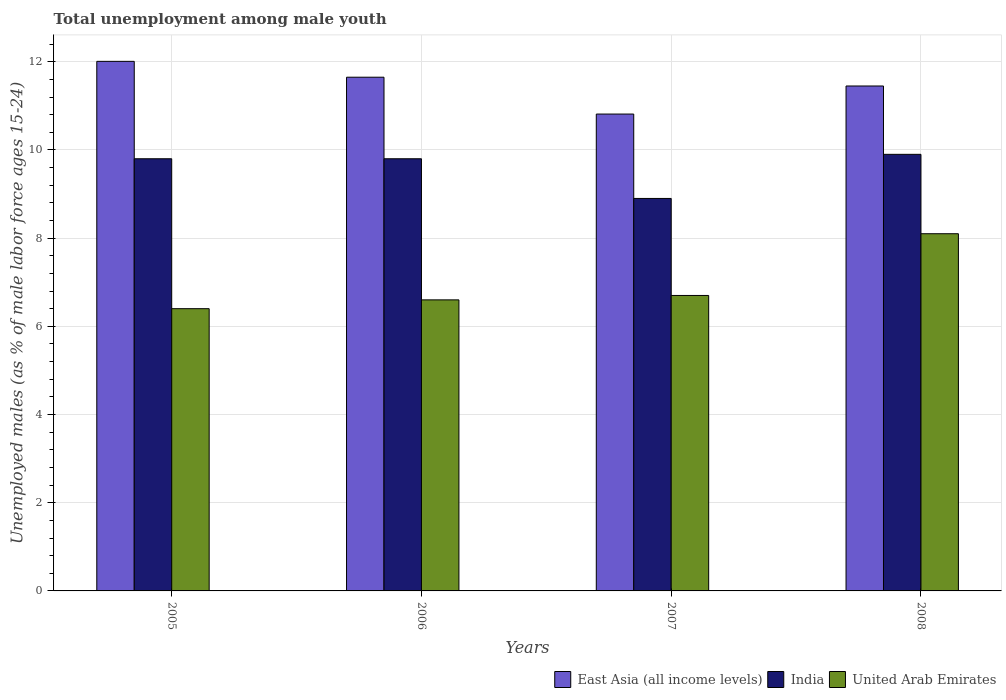How many groups of bars are there?
Ensure brevity in your answer.  4. Are the number of bars per tick equal to the number of legend labels?
Offer a very short reply. Yes. How many bars are there on the 3rd tick from the left?
Keep it short and to the point. 3. What is the percentage of unemployed males in in India in 2008?
Offer a terse response. 9.9. Across all years, what is the maximum percentage of unemployed males in in East Asia (all income levels)?
Make the answer very short. 12.01. Across all years, what is the minimum percentage of unemployed males in in East Asia (all income levels)?
Your response must be concise. 10.81. In which year was the percentage of unemployed males in in United Arab Emirates maximum?
Give a very brief answer. 2008. In which year was the percentage of unemployed males in in India minimum?
Your answer should be compact. 2007. What is the total percentage of unemployed males in in United Arab Emirates in the graph?
Make the answer very short. 27.8. What is the difference between the percentage of unemployed males in in United Arab Emirates in 2005 and that in 2008?
Your answer should be compact. -1.7. What is the difference between the percentage of unemployed males in in India in 2007 and the percentage of unemployed males in in East Asia (all income levels) in 2005?
Give a very brief answer. -3.11. What is the average percentage of unemployed males in in United Arab Emirates per year?
Provide a succinct answer. 6.95. In the year 2008, what is the difference between the percentage of unemployed males in in United Arab Emirates and percentage of unemployed males in in India?
Offer a terse response. -1.8. In how many years, is the percentage of unemployed males in in United Arab Emirates greater than 6.4 %?
Ensure brevity in your answer.  4. What is the ratio of the percentage of unemployed males in in East Asia (all income levels) in 2006 to that in 2007?
Keep it short and to the point. 1.08. Is the difference between the percentage of unemployed males in in United Arab Emirates in 2007 and 2008 greater than the difference between the percentage of unemployed males in in India in 2007 and 2008?
Offer a terse response. No. What is the difference between the highest and the second highest percentage of unemployed males in in United Arab Emirates?
Your answer should be very brief. 1.4. What is the difference between the highest and the lowest percentage of unemployed males in in East Asia (all income levels)?
Provide a succinct answer. 1.2. In how many years, is the percentage of unemployed males in in United Arab Emirates greater than the average percentage of unemployed males in in United Arab Emirates taken over all years?
Provide a succinct answer. 1. Is the sum of the percentage of unemployed males in in East Asia (all income levels) in 2006 and 2007 greater than the maximum percentage of unemployed males in in United Arab Emirates across all years?
Offer a very short reply. Yes. What does the 1st bar from the left in 2005 represents?
Provide a short and direct response. East Asia (all income levels). What does the 3rd bar from the right in 2006 represents?
Keep it short and to the point. East Asia (all income levels). Is it the case that in every year, the sum of the percentage of unemployed males in in East Asia (all income levels) and percentage of unemployed males in in India is greater than the percentage of unemployed males in in United Arab Emirates?
Make the answer very short. Yes. How many bars are there?
Your response must be concise. 12. What is the difference between two consecutive major ticks on the Y-axis?
Offer a terse response. 2. Are the values on the major ticks of Y-axis written in scientific E-notation?
Your answer should be compact. No. Does the graph contain any zero values?
Ensure brevity in your answer.  No. Does the graph contain grids?
Give a very brief answer. Yes. How are the legend labels stacked?
Your response must be concise. Horizontal. What is the title of the graph?
Keep it short and to the point. Total unemployment among male youth. What is the label or title of the Y-axis?
Make the answer very short. Unemployed males (as % of male labor force ages 15-24). What is the Unemployed males (as % of male labor force ages 15-24) in East Asia (all income levels) in 2005?
Offer a very short reply. 12.01. What is the Unemployed males (as % of male labor force ages 15-24) of India in 2005?
Offer a very short reply. 9.8. What is the Unemployed males (as % of male labor force ages 15-24) of United Arab Emirates in 2005?
Keep it short and to the point. 6.4. What is the Unemployed males (as % of male labor force ages 15-24) in East Asia (all income levels) in 2006?
Offer a terse response. 11.65. What is the Unemployed males (as % of male labor force ages 15-24) in India in 2006?
Your answer should be very brief. 9.8. What is the Unemployed males (as % of male labor force ages 15-24) of United Arab Emirates in 2006?
Provide a short and direct response. 6.6. What is the Unemployed males (as % of male labor force ages 15-24) in East Asia (all income levels) in 2007?
Provide a succinct answer. 10.81. What is the Unemployed males (as % of male labor force ages 15-24) of India in 2007?
Offer a terse response. 8.9. What is the Unemployed males (as % of male labor force ages 15-24) in United Arab Emirates in 2007?
Ensure brevity in your answer.  6.7. What is the Unemployed males (as % of male labor force ages 15-24) in East Asia (all income levels) in 2008?
Provide a succinct answer. 11.45. What is the Unemployed males (as % of male labor force ages 15-24) in India in 2008?
Offer a terse response. 9.9. What is the Unemployed males (as % of male labor force ages 15-24) in United Arab Emirates in 2008?
Your answer should be compact. 8.1. Across all years, what is the maximum Unemployed males (as % of male labor force ages 15-24) in East Asia (all income levels)?
Provide a short and direct response. 12.01. Across all years, what is the maximum Unemployed males (as % of male labor force ages 15-24) in India?
Offer a terse response. 9.9. Across all years, what is the maximum Unemployed males (as % of male labor force ages 15-24) in United Arab Emirates?
Provide a succinct answer. 8.1. Across all years, what is the minimum Unemployed males (as % of male labor force ages 15-24) of East Asia (all income levels)?
Provide a succinct answer. 10.81. Across all years, what is the minimum Unemployed males (as % of male labor force ages 15-24) in India?
Your response must be concise. 8.9. Across all years, what is the minimum Unemployed males (as % of male labor force ages 15-24) in United Arab Emirates?
Make the answer very short. 6.4. What is the total Unemployed males (as % of male labor force ages 15-24) in East Asia (all income levels) in the graph?
Provide a short and direct response. 45.92. What is the total Unemployed males (as % of male labor force ages 15-24) in India in the graph?
Keep it short and to the point. 38.4. What is the total Unemployed males (as % of male labor force ages 15-24) of United Arab Emirates in the graph?
Offer a terse response. 27.8. What is the difference between the Unemployed males (as % of male labor force ages 15-24) in East Asia (all income levels) in 2005 and that in 2006?
Ensure brevity in your answer.  0.36. What is the difference between the Unemployed males (as % of male labor force ages 15-24) in East Asia (all income levels) in 2005 and that in 2007?
Give a very brief answer. 1.2. What is the difference between the Unemployed males (as % of male labor force ages 15-24) in India in 2005 and that in 2007?
Offer a very short reply. 0.9. What is the difference between the Unemployed males (as % of male labor force ages 15-24) of East Asia (all income levels) in 2005 and that in 2008?
Offer a very short reply. 0.56. What is the difference between the Unemployed males (as % of male labor force ages 15-24) of India in 2005 and that in 2008?
Offer a terse response. -0.1. What is the difference between the Unemployed males (as % of male labor force ages 15-24) in East Asia (all income levels) in 2006 and that in 2007?
Your response must be concise. 0.84. What is the difference between the Unemployed males (as % of male labor force ages 15-24) of India in 2006 and that in 2007?
Your answer should be very brief. 0.9. What is the difference between the Unemployed males (as % of male labor force ages 15-24) in East Asia (all income levels) in 2006 and that in 2008?
Provide a short and direct response. 0.2. What is the difference between the Unemployed males (as % of male labor force ages 15-24) in United Arab Emirates in 2006 and that in 2008?
Offer a terse response. -1.5. What is the difference between the Unemployed males (as % of male labor force ages 15-24) in East Asia (all income levels) in 2007 and that in 2008?
Your response must be concise. -0.64. What is the difference between the Unemployed males (as % of male labor force ages 15-24) of India in 2007 and that in 2008?
Keep it short and to the point. -1. What is the difference between the Unemployed males (as % of male labor force ages 15-24) of East Asia (all income levels) in 2005 and the Unemployed males (as % of male labor force ages 15-24) of India in 2006?
Offer a terse response. 2.21. What is the difference between the Unemployed males (as % of male labor force ages 15-24) in East Asia (all income levels) in 2005 and the Unemployed males (as % of male labor force ages 15-24) in United Arab Emirates in 2006?
Offer a very short reply. 5.41. What is the difference between the Unemployed males (as % of male labor force ages 15-24) of East Asia (all income levels) in 2005 and the Unemployed males (as % of male labor force ages 15-24) of India in 2007?
Your answer should be very brief. 3.11. What is the difference between the Unemployed males (as % of male labor force ages 15-24) in East Asia (all income levels) in 2005 and the Unemployed males (as % of male labor force ages 15-24) in United Arab Emirates in 2007?
Provide a short and direct response. 5.31. What is the difference between the Unemployed males (as % of male labor force ages 15-24) in East Asia (all income levels) in 2005 and the Unemployed males (as % of male labor force ages 15-24) in India in 2008?
Make the answer very short. 2.11. What is the difference between the Unemployed males (as % of male labor force ages 15-24) of East Asia (all income levels) in 2005 and the Unemployed males (as % of male labor force ages 15-24) of United Arab Emirates in 2008?
Give a very brief answer. 3.91. What is the difference between the Unemployed males (as % of male labor force ages 15-24) in India in 2005 and the Unemployed males (as % of male labor force ages 15-24) in United Arab Emirates in 2008?
Keep it short and to the point. 1.7. What is the difference between the Unemployed males (as % of male labor force ages 15-24) of East Asia (all income levels) in 2006 and the Unemployed males (as % of male labor force ages 15-24) of India in 2007?
Offer a terse response. 2.75. What is the difference between the Unemployed males (as % of male labor force ages 15-24) of East Asia (all income levels) in 2006 and the Unemployed males (as % of male labor force ages 15-24) of United Arab Emirates in 2007?
Your answer should be compact. 4.95. What is the difference between the Unemployed males (as % of male labor force ages 15-24) of India in 2006 and the Unemployed males (as % of male labor force ages 15-24) of United Arab Emirates in 2007?
Provide a short and direct response. 3.1. What is the difference between the Unemployed males (as % of male labor force ages 15-24) of East Asia (all income levels) in 2006 and the Unemployed males (as % of male labor force ages 15-24) of India in 2008?
Make the answer very short. 1.75. What is the difference between the Unemployed males (as % of male labor force ages 15-24) in East Asia (all income levels) in 2006 and the Unemployed males (as % of male labor force ages 15-24) in United Arab Emirates in 2008?
Offer a terse response. 3.55. What is the difference between the Unemployed males (as % of male labor force ages 15-24) of India in 2006 and the Unemployed males (as % of male labor force ages 15-24) of United Arab Emirates in 2008?
Your response must be concise. 1.7. What is the difference between the Unemployed males (as % of male labor force ages 15-24) in East Asia (all income levels) in 2007 and the Unemployed males (as % of male labor force ages 15-24) in India in 2008?
Give a very brief answer. 0.91. What is the difference between the Unemployed males (as % of male labor force ages 15-24) in East Asia (all income levels) in 2007 and the Unemployed males (as % of male labor force ages 15-24) in United Arab Emirates in 2008?
Provide a succinct answer. 2.71. What is the average Unemployed males (as % of male labor force ages 15-24) in East Asia (all income levels) per year?
Your answer should be very brief. 11.48. What is the average Unemployed males (as % of male labor force ages 15-24) in India per year?
Your answer should be compact. 9.6. What is the average Unemployed males (as % of male labor force ages 15-24) in United Arab Emirates per year?
Provide a succinct answer. 6.95. In the year 2005, what is the difference between the Unemployed males (as % of male labor force ages 15-24) of East Asia (all income levels) and Unemployed males (as % of male labor force ages 15-24) of India?
Ensure brevity in your answer.  2.21. In the year 2005, what is the difference between the Unemployed males (as % of male labor force ages 15-24) of East Asia (all income levels) and Unemployed males (as % of male labor force ages 15-24) of United Arab Emirates?
Provide a succinct answer. 5.61. In the year 2005, what is the difference between the Unemployed males (as % of male labor force ages 15-24) of India and Unemployed males (as % of male labor force ages 15-24) of United Arab Emirates?
Your response must be concise. 3.4. In the year 2006, what is the difference between the Unemployed males (as % of male labor force ages 15-24) of East Asia (all income levels) and Unemployed males (as % of male labor force ages 15-24) of India?
Give a very brief answer. 1.85. In the year 2006, what is the difference between the Unemployed males (as % of male labor force ages 15-24) in East Asia (all income levels) and Unemployed males (as % of male labor force ages 15-24) in United Arab Emirates?
Offer a very short reply. 5.05. In the year 2007, what is the difference between the Unemployed males (as % of male labor force ages 15-24) in East Asia (all income levels) and Unemployed males (as % of male labor force ages 15-24) in India?
Give a very brief answer. 1.91. In the year 2007, what is the difference between the Unemployed males (as % of male labor force ages 15-24) in East Asia (all income levels) and Unemployed males (as % of male labor force ages 15-24) in United Arab Emirates?
Your response must be concise. 4.11. In the year 2008, what is the difference between the Unemployed males (as % of male labor force ages 15-24) in East Asia (all income levels) and Unemployed males (as % of male labor force ages 15-24) in India?
Offer a terse response. 1.55. In the year 2008, what is the difference between the Unemployed males (as % of male labor force ages 15-24) of East Asia (all income levels) and Unemployed males (as % of male labor force ages 15-24) of United Arab Emirates?
Provide a short and direct response. 3.35. What is the ratio of the Unemployed males (as % of male labor force ages 15-24) of East Asia (all income levels) in 2005 to that in 2006?
Offer a very short reply. 1.03. What is the ratio of the Unemployed males (as % of male labor force ages 15-24) in India in 2005 to that in 2006?
Your answer should be very brief. 1. What is the ratio of the Unemployed males (as % of male labor force ages 15-24) in United Arab Emirates in 2005 to that in 2006?
Give a very brief answer. 0.97. What is the ratio of the Unemployed males (as % of male labor force ages 15-24) in East Asia (all income levels) in 2005 to that in 2007?
Your answer should be compact. 1.11. What is the ratio of the Unemployed males (as % of male labor force ages 15-24) of India in 2005 to that in 2007?
Provide a succinct answer. 1.1. What is the ratio of the Unemployed males (as % of male labor force ages 15-24) in United Arab Emirates in 2005 to that in 2007?
Your response must be concise. 0.96. What is the ratio of the Unemployed males (as % of male labor force ages 15-24) in East Asia (all income levels) in 2005 to that in 2008?
Offer a terse response. 1.05. What is the ratio of the Unemployed males (as % of male labor force ages 15-24) of United Arab Emirates in 2005 to that in 2008?
Ensure brevity in your answer.  0.79. What is the ratio of the Unemployed males (as % of male labor force ages 15-24) in East Asia (all income levels) in 2006 to that in 2007?
Provide a succinct answer. 1.08. What is the ratio of the Unemployed males (as % of male labor force ages 15-24) in India in 2006 to that in 2007?
Your answer should be compact. 1.1. What is the ratio of the Unemployed males (as % of male labor force ages 15-24) in United Arab Emirates in 2006 to that in 2007?
Provide a short and direct response. 0.99. What is the ratio of the Unemployed males (as % of male labor force ages 15-24) in East Asia (all income levels) in 2006 to that in 2008?
Keep it short and to the point. 1.02. What is the ratio of the Unemployed males (as % of male labor force ages 15-24) of United Arab Emirates in 2006 to that in 2008?
Provide a short and direct response. 0.81. What is the ratio of the Unemployed males (as % of male labor force ages 15-24) of East Asia (all income levels) in 2007 to that in 2008?
Your answer should be very brief. 0.94. What is the ratio of the Unemployed males (as % of male labor force ages 15-24) in India in 2007 to that in 2008?
Offer a terse response. 0.9. What is the ratio of the Unemployed males (as % of male labor force ages 15-24) of United Arab Emirates in 2007 to that in 2008?
Provide a short and direct response. 0.83. What is the difference between the highest and the second highest Unemployed males (as % of male labor force ages 15-24) of East Asia (all income levels)?
Provide a short and direct response. 0.36. What is the difference between the highest and the lowest Unemployed males (as % of male labor force ages 15-24) of East Asia (all income levels)?
Your response must be concise. 1.2. What is the difference between the highest and the lowest Unemployed males (as % of male labor force ages 15-24) of India?
Offer a very short reply. 1. 